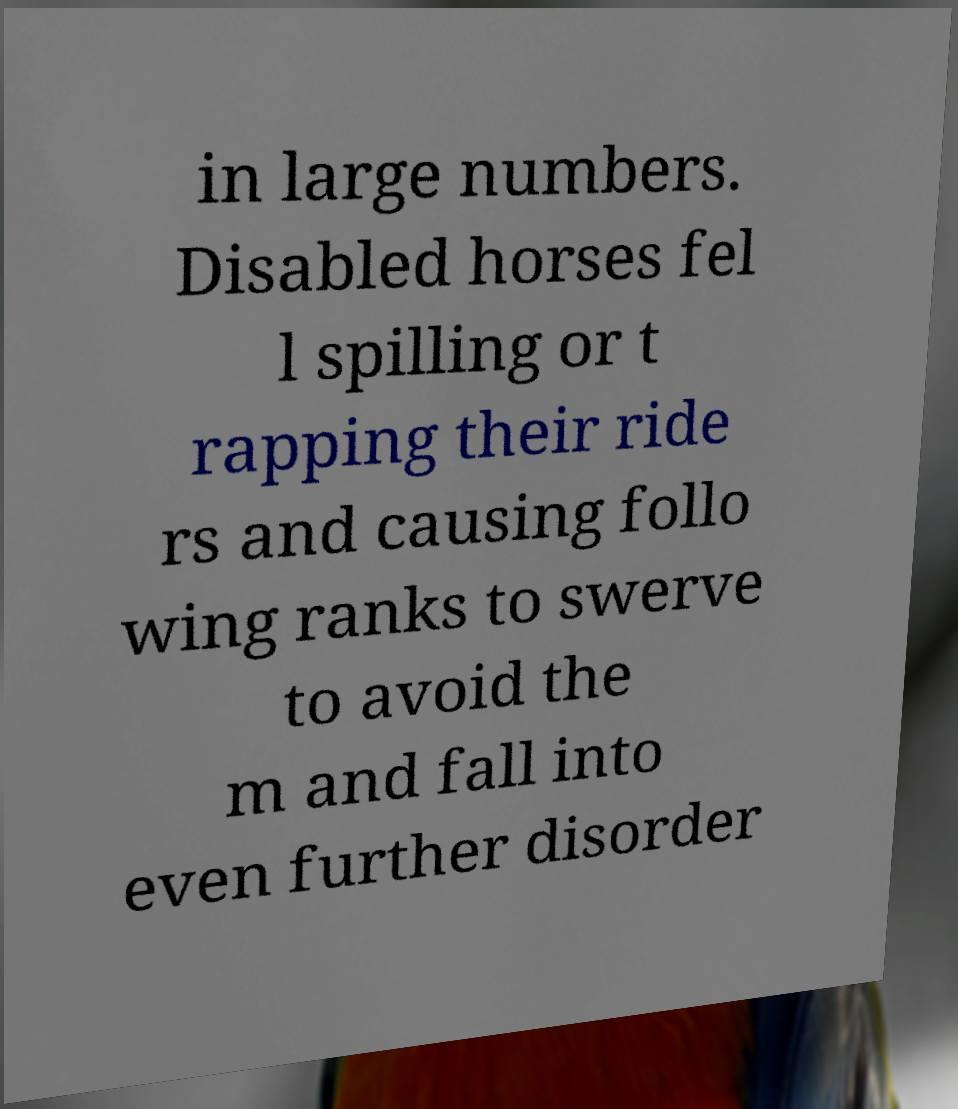Could you assist in decoding the text presented in this image and type it out clearly? in large numbers. Disabled horses fel l spilling or t rapping their ride rs and causing follo wing ranks to swerve to avoid the m and fall into even further disorder 